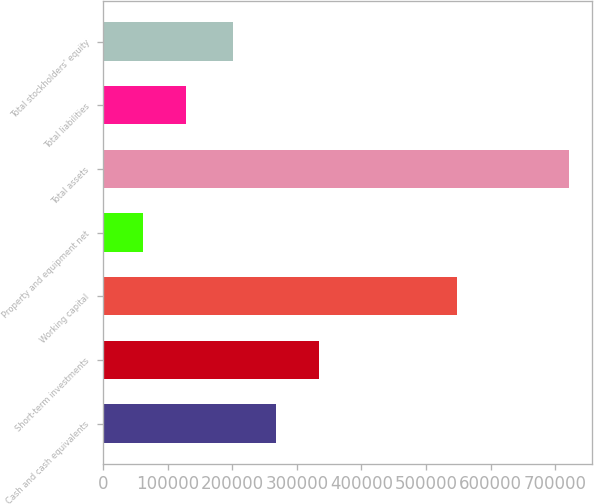Convert chart. <chart><loc_0><loc_0><loc_500><loc_500><bar_chart><fcel>Cash and cash equivalents<fcel>Short-term investments<fcel>Working capital<fcel>Property and equipment net<fcel>Total assets<fcel>Total liabilities<fcel>Total stockholders' equity<nl><fcel>267707<fcel>333576<fcel>548324<fcel>61983<fcel>720675<fcel>127852<fcel>201838<nl></chart> 